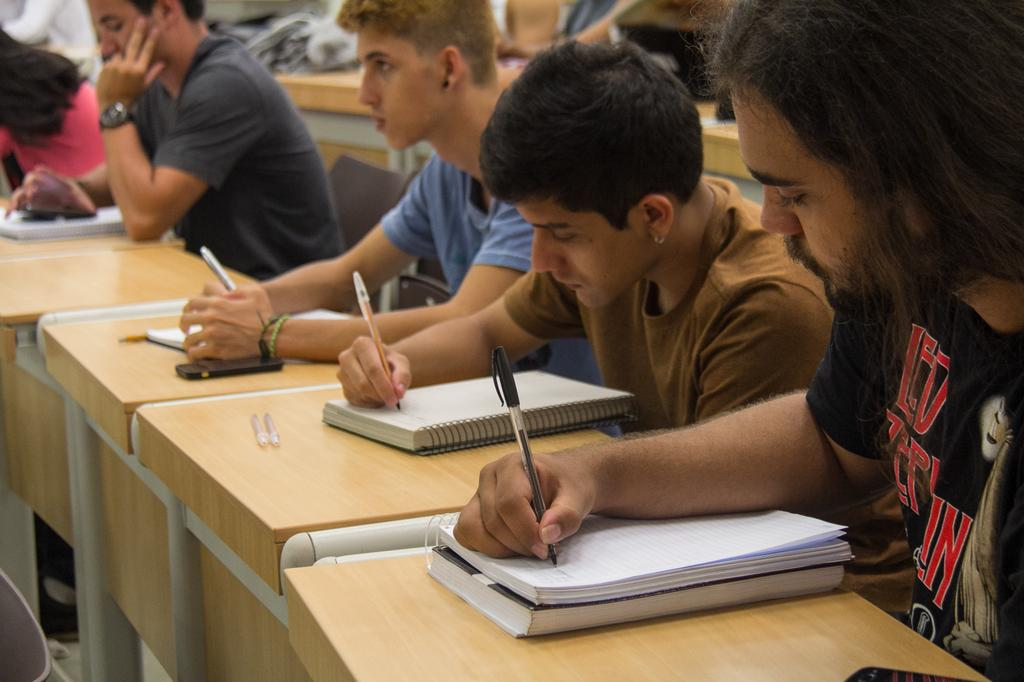Provide a one-sentence caption for the provided image. People in a class hold pens and write in notebooks, one of the men wears a Led Zeplin shirt. 